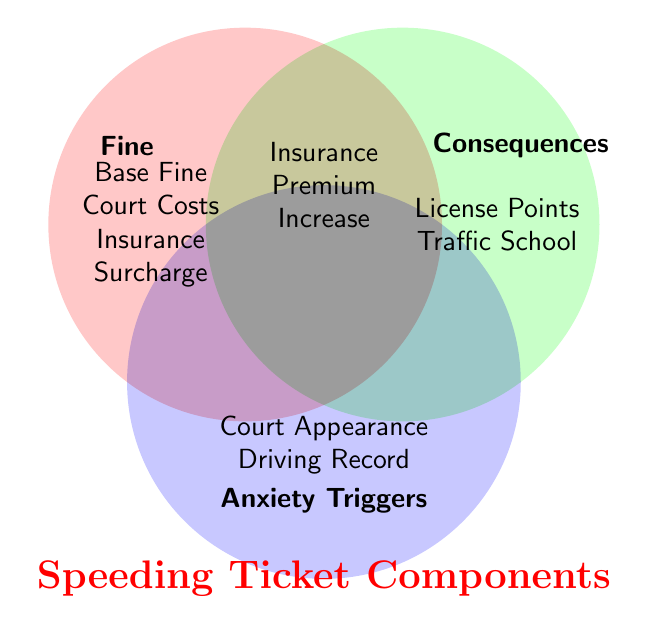What are the components of a speeding ticket fine? The components of a speeding ticket fine can be identified in the circle labeled "Fine" within the Venn Diagram. These components include Base Fine, Court Costs, and Insurance Surcharge.
Answer: Base Fine, Court Costs, Insurance Surcharge Which elements are common between fines and anxiety triggers? The overlapping region between the "Fine" circle and the "Anxiety Triggers" circle shows the common elements. These include Base Fine and Court Appearance.
Answer: Base Fine, Court Appearance What anxiety triggers are related to insurance? Within the "Anxiety Triggers" circle, the elements related to insurance that trigger anxiety can be found intersecting with other circles. The specific element is Insurance Premium Increase.
Answer: Insurance Premium Increase Which components fall under consequences but not under anxiety triggers? To find this, look in the "Consequences" circle and avoid the overlap with "Anxiety Triggers". The components here are Driver's License Points and Traffic School.
Answer: Driver's License Points, Traffic School What component is related to all three categories: fines, consequences, and anxiety triggers? The intersection of all three circles, "Fine", "Consequences", and "Anxiety Triggers", shows the component common to all. This component is the Insurance Premium Increase.
Answer: Insurance Premium Increase What are the components that only fall under fines? The sections of the "Fine" circle that do not overlap with any other circle show components unique to fines. These include Court Costs and Insurance Surcharge.
Answer: Court Costs, Insurance Surcharge Which consequences are also anxiety triggers? The overlapping region between the "Consequences" circle and the "Anxiety Triggers" circles shows the common elements. These include Insurance Premium Increase and Driving Record Impact.
Answer: Insurance Premium Increase, Driving Record Impact What component is a cause of anxiety but not a consequence? Within the "Anxiety Triggers" circle, exclude the overlap with the "Consequences" circle. Remaining elements include Court Appearance and Driving Record Impact.
Answer: Court Appearance, Driving Record Impact 